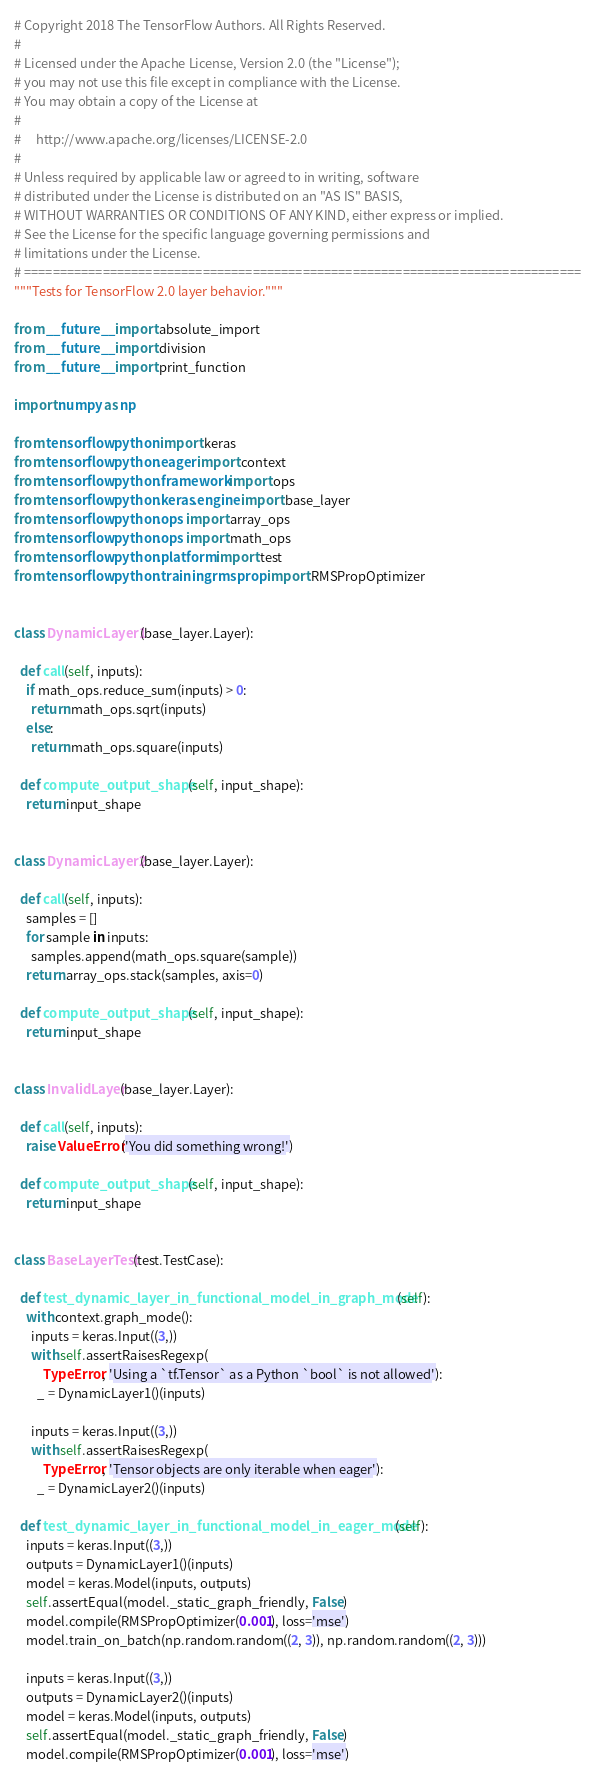<code> <loc_0><loc_0><loc_500><loc_500><_Python_># Copyright 2018 The TensorFlow Authors. All Rights Reserved.
#
# Licensed under the Apache License, Version 2.0 (the "License");
# you may not use this file except in compliance with the License.
# You may obtain a copy of the License at
#
#     http://www.apache.org/licenses/LICENSE-2.0
#
# Unless required by applicable law or agreed to in writing, software
# distributed under the License is distributed on an "AS IS" BASIS,
# WITHOUT WARRANTIES OR CONDITIONS OF ANY KIND, either express or implied.
# See the License for the specific language governing permissions and
# limitations under the License.
# ==============================================================================
"""Tests for TensorFlow 2.0 layer behavior."""

from __future__ import absolute_import
from __future__ import division
from __future__ import print_function

import numpy as np

from tensorflow.python import keras
from tensorflow.python.eager import context
from tensorflow.python.framework import ops
from tensorflow.python.keras.engine import base_layer
from tensorflow.python.ops import array_ops
from tensorflow.python.ops import math_ops
from tensorflow.python.platform import test
from tensorflow.python.training.rmsprop import RMSPropOptimizer


class DynamicLayer1(base_layer.Layer):

  def call(self, inputs):
    if math_ops.reduce_sum(inputs) > 0:
      return math_ops.sqrt(inputs)
    else:
      return math_ops.square(inputs)

  def compute_output_shape(self, input_shape):
    return input_shape


class DynamicLayer2(base_layer.Layer):

  def call(self, inputs):
    samples = []
    for sample in inputs:
      samples.append(math_ops.square(sample))
    return array_ops.stack(samples, axis=0)

  def compute_output_shape(self, input_shape):
    return input_shape


class InvalidLayer(base_layer.Layer):

  def call(self, inputs):
    raise ValueError('You did something wrong!')

  def compute_output_shape(self, input_shape):
    return input_shape


class BaseLayerTest(test.TestCase):

  def test_dynamic_layer_in_functional_model_in_graph_mode(self):
    with context.graph_mode():
      inputs = keras.Input((3,))
      with self.assertRaisesRegexp(
          TypeError, 'Using a `tf.Tensor` as a Python `bool` is not allowed'):
        _ = DynamicLayer1()(inputs)

      inputs = keras.Input((3,))
      with self.assertRaisesRegexp(
          TypeError, 'Tensor objects are only iterable when eager'):
        _ = DynamicLayer2()(inputs)

  def test_dynamic_layer_in_functional_model_in_eager_mode(self):
    inputs = keras.Input((3,))
    outputs = DynamicLayer1()(inputs)
    model = keras.Model(inputs, outputs)
    self.assertEqual(model._static_graph_friendly, False)
    model.compile(RMSPropOptimizer(0.001), loss='mse')
    model.train_on_batch(np.random.random((2, 3)), np.random.random((2, 3)))

    inputs = keras.Input((3,))
    outputs = DynamicLayer2()(inputs)
    model = keras.Model(inputs, outputs)
    self.assertEqual(model._static_graph_friendly, False)
    model.compile(RMSPropOptimizer(0.001), loss='mse')</code> 